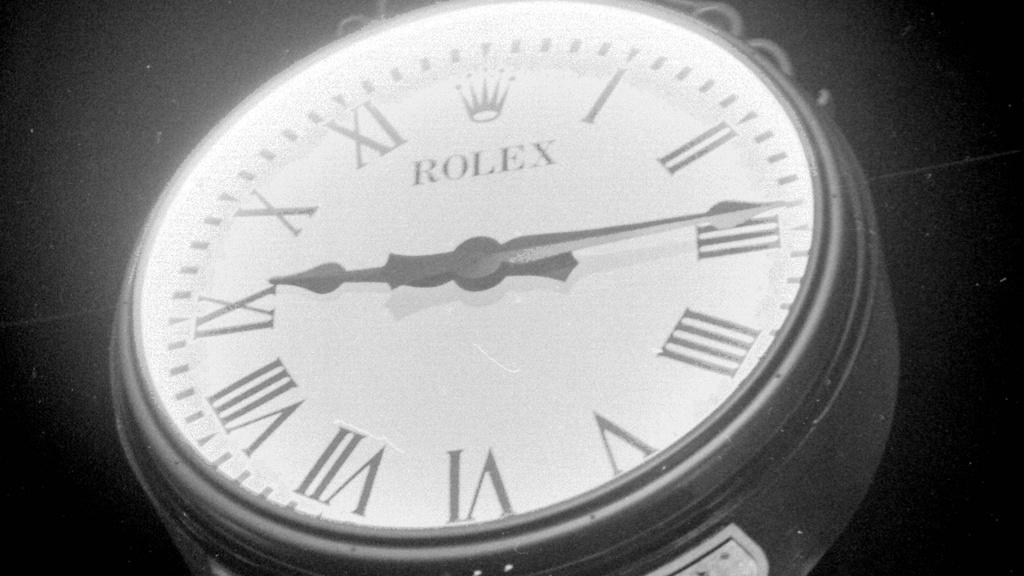<image>
Provide a brief description of the given image. Face of a Rolex watch with the hands at 9 and 3. 